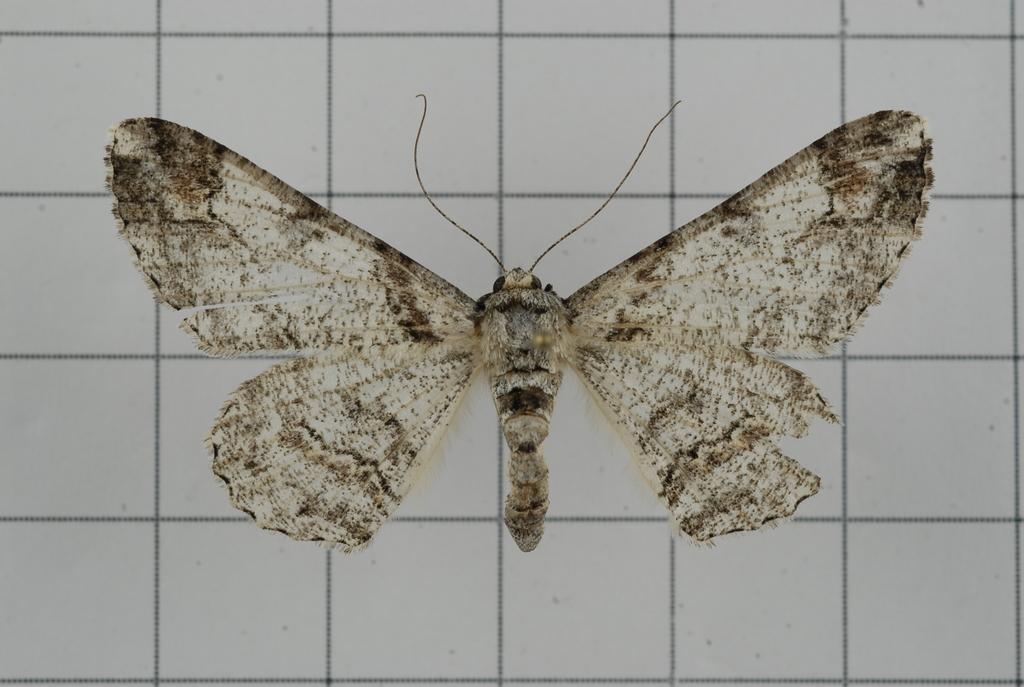In one or two sentences, can you explain what this image depicts? The picture consists of a butterfly on a graph. 